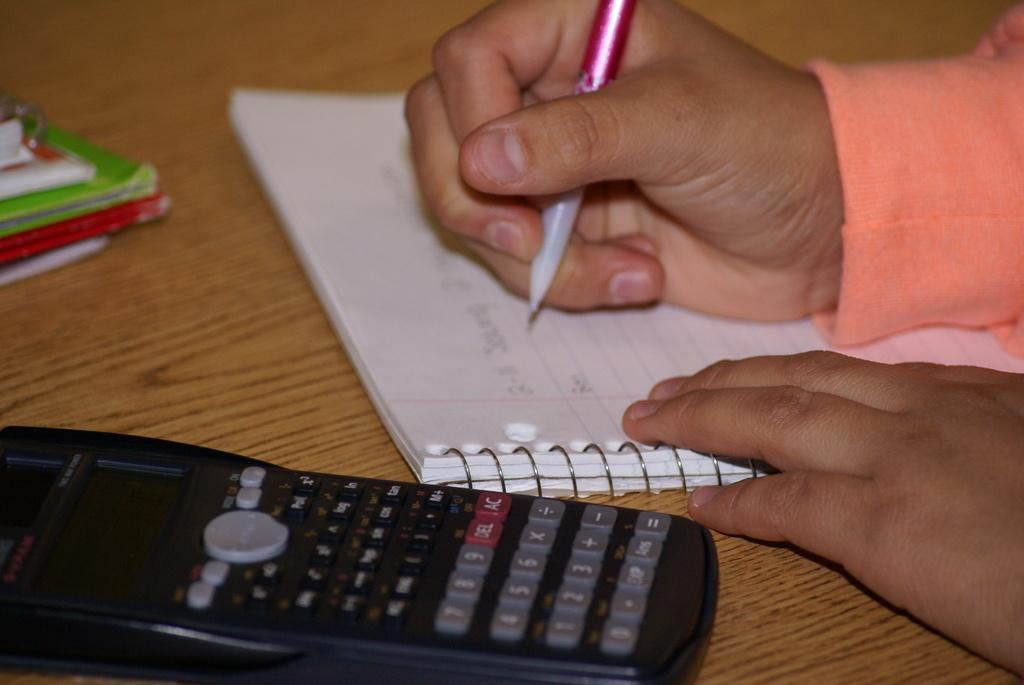Provide a one-sentence caption for the provided image. A calculator with a red delete button is on a table. 